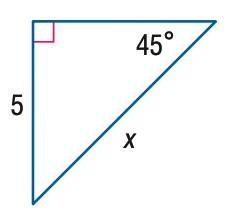Answer the mathemtical geometry problem and directly provide the correct option letter.
Question: Find x.
Choices: A: 5 B: 5 \sqrt { 2 } C: 5 \sqrt { 3 } D: 10 B 